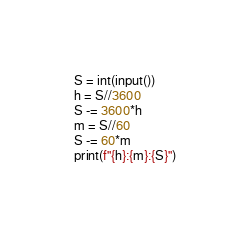Convert code to text. <code><loc_0><loc_0><loc_500><loc_500><_Python_>S = int(input())
h = S//3600
S -= 3600*h
m = S//60
S -= 60*m
print(f"{h}:{m}:{S}")
</code> 